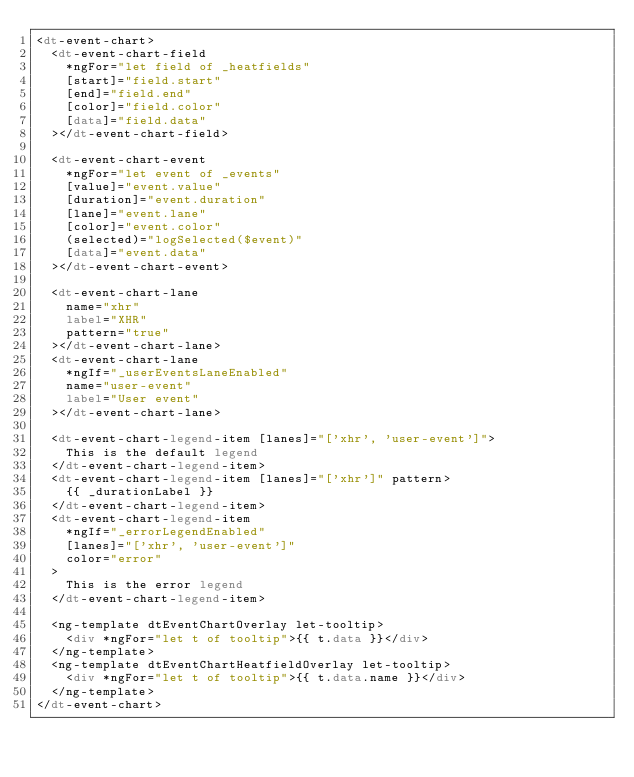Convert code to text. <code><loc_0><loc_0><loc_500><loc_500><_HTML_><dt-event-chart>
  <dt-event-chart-field
    *ngFor="let field of _heatfields"
    [start]="field.start"
    [end]="field.end"
    [color]="field.color"
    [data]="field.data"
  ></dt-event-chart-field>

  <dt-event-chart-event
    *ngFor="let event of _events"
    [value]="event.value"
    [duration]="event.duration"
    [lane]="event.lane"
    [color]="event.color"
    (selected)="logSelected($event)"
    [data]="event.data"
  ></dt-event-chart-event>

  <dt-event-chart-lane
    name="xhr"
    label="XHR"
    pattern="true"
  ></dt-event-chart-lane>
  <dt-event-chart-lane
    *ngIf="_userEventsLaneEnabled"
    name="user-event"
    label="User event"
  ></dt-event-chart-lane>

  <dt-event-chart-legend-item [lanes]="['xhr', 'user-event']">
    This is the default legend
  </dt-event-chart-legend-item>
  <dt-event-chart-legend-item [lanes]="['xhr']" pattern>
    {{ _durationLabel }}
  </dt-event-chart-legend-item>
  <dt-event-chart-legend-item
    *ngIf="_errorLegendEnabled"
    [lanes]="['xhr', 'user-event']"
    color="error"
  >
    This is the error legend
  </dt-event-chart-legend-item>

  <ng-template dtEventChartOverlay let-tooltip>
    <div *ngFor="let t of tooltip">{{ t.data }}</div>
  </ng-template>
  <ng-template dtEventChartHeatfieldOverlay let-tooltip>
    <div *ngFor="let t of tooltip">{{ t.data.name }}</div>
  </ng-template>
</dt-event-chart>
</code> 